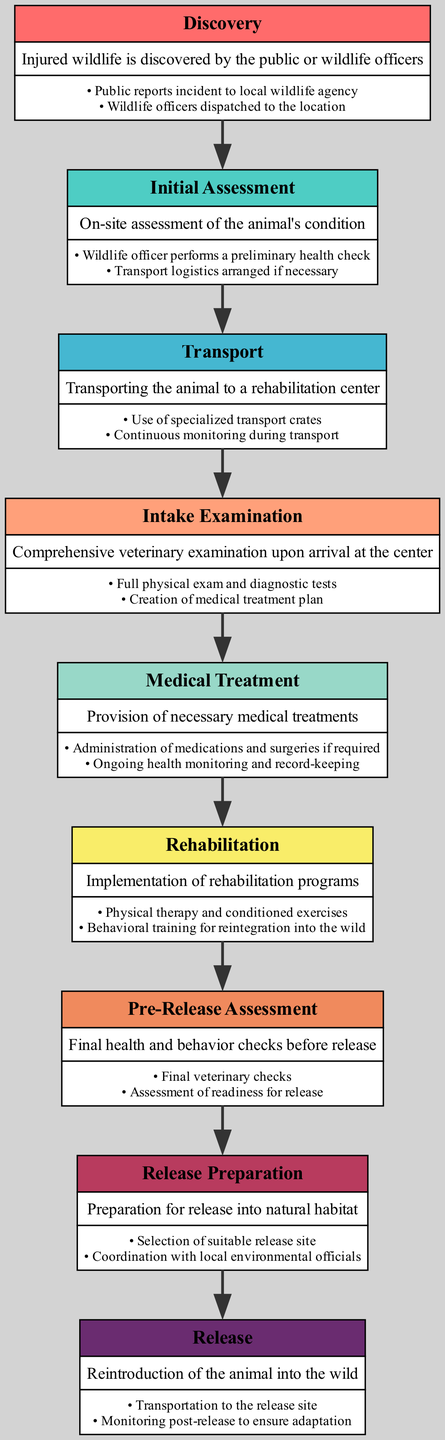What is the first step in the pathway? The first step in the pathway is clearly labeled as "Discovery." It is located at the top of the diagram, indicating the beginning of the process.
Answer: Discovery How many main steps are there in the clinical pathway? By counting each distinct step provided in the diagram, we see there are a total of 9 main steps arranged in a sequential order.
Answer: 9 What follows the Initial Assessment step? The following step directly after "Initial Assessment" is "Transport," which is indicated by the arrow leading to the next node in the pathway.
Answer: Transport What is a key action during the Medical Treatment step? A key action listed under the "Medical Treatment" step is "Administration of medications and surgeries if required." This action highlights the necessary treatments performed at this stage.
Answer: Administration of medications and surgeries if required What is the last step before the animal is released? The last step before release is "Release Preparation," which involves actions to get the animal ready for its return to the wild, as shown immediately before the final release step.
Answer: Release Preparation Which step involves both physical therapy and behavioral training? The step that includes both "Physical therapy and conditioned exercises" and "Behavioral training for reintegration into the wild" is "Rehabilitation." This is essential for the animal’s recovery and adaptation.
Answer: Rehabilitation Which step has a description that includes arranging transport logistics? The "Initial Assessment" step includes the action of "Transport logistics arranged if necessary," indicating plans for moving the animal if needed based on its condition assessed on-site.
Answer: Initial Assessment What type of examination is done during the Intake Examination step? The "Intake Examination" step refers to a "Comprehensive veterinary examination," which is crucial for developing a treatment plan. This step primarily focuses on assessing the animal's health upon arrival at the rehabilitation center.
Answer: Comprehensive veterinary examination What is the main difference between the Pre-Release Assessment and Release Preparation steps? The "Pre-Release Assessment" focuses on final checks of health and behavior, while "Release Preparation" involves selecting a suitable release site and coordinating with officials, indicating the transition from assessment to actual preparation for release.
Answer: Focus on final checks vs. preparation for release 